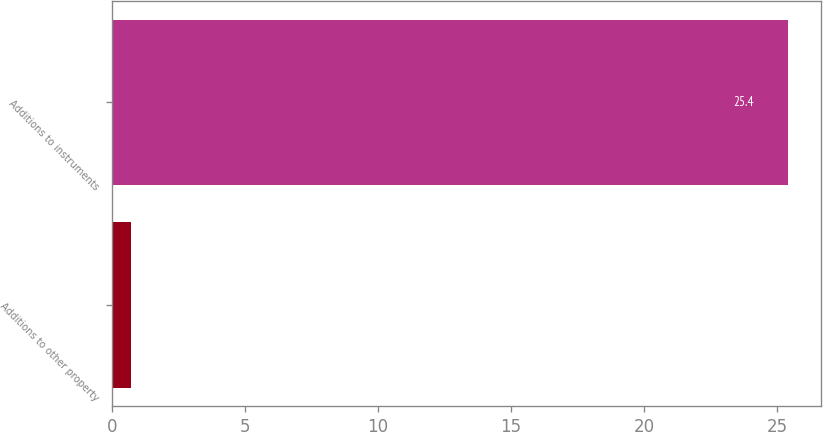Convert chart. <chart><loc_0><loc_0><loc_500><loc_500><bar_chart><fcel>Additions to other property<fcel>Additions to instruments<nl><fcel>0.7<fcel>25.4<nl></chart> 